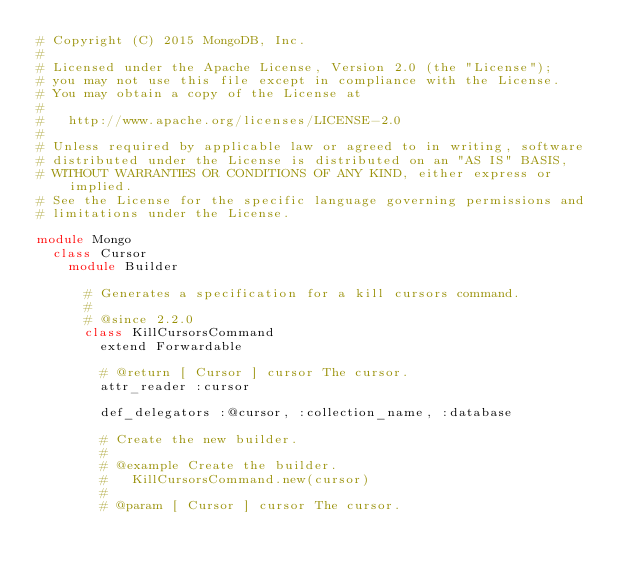<code> <loc_0><loc_0><loc_500><loc_500><_Ruby_># Copyright (C) 2015 MongoDB, Inc.
#
# Licensed under the Apache License, Version 2.0 (the "License");
# you may not use this file except in compliance with the License.
# You may obtain a copy of the License at
#
#   http://www.apache.org/licenses/LICENSE-2.0
#
# Unless required by applicable law or agreed to in writing, software
# distributed under the License is distributed on an "AS IS" BASIS,
# WITHOUT WARRANTIES OR CONDITIONS OF ANY KIND, either express or implied.
# See the License for the specific language governing permissions and
# limitations under the License.

module Mongo
  class Cursor
    module Builder

      # Generates a specification for a kill cursors command.
      #
      # @since 2.2.0
      class KillCursorsCommand
        extend Forwardable

        # @return [ Cursor ] cursor The cursor.
        attr_reader :cursor

        def_delegators :@cursor, :collection_name, :database

        # Create the new builder.
        #
        # @example Create the builder.
        #   KillCursorsCommand.new(cursor)
        #
        # @param [ Cursor ] cursor The cursor.</code> 